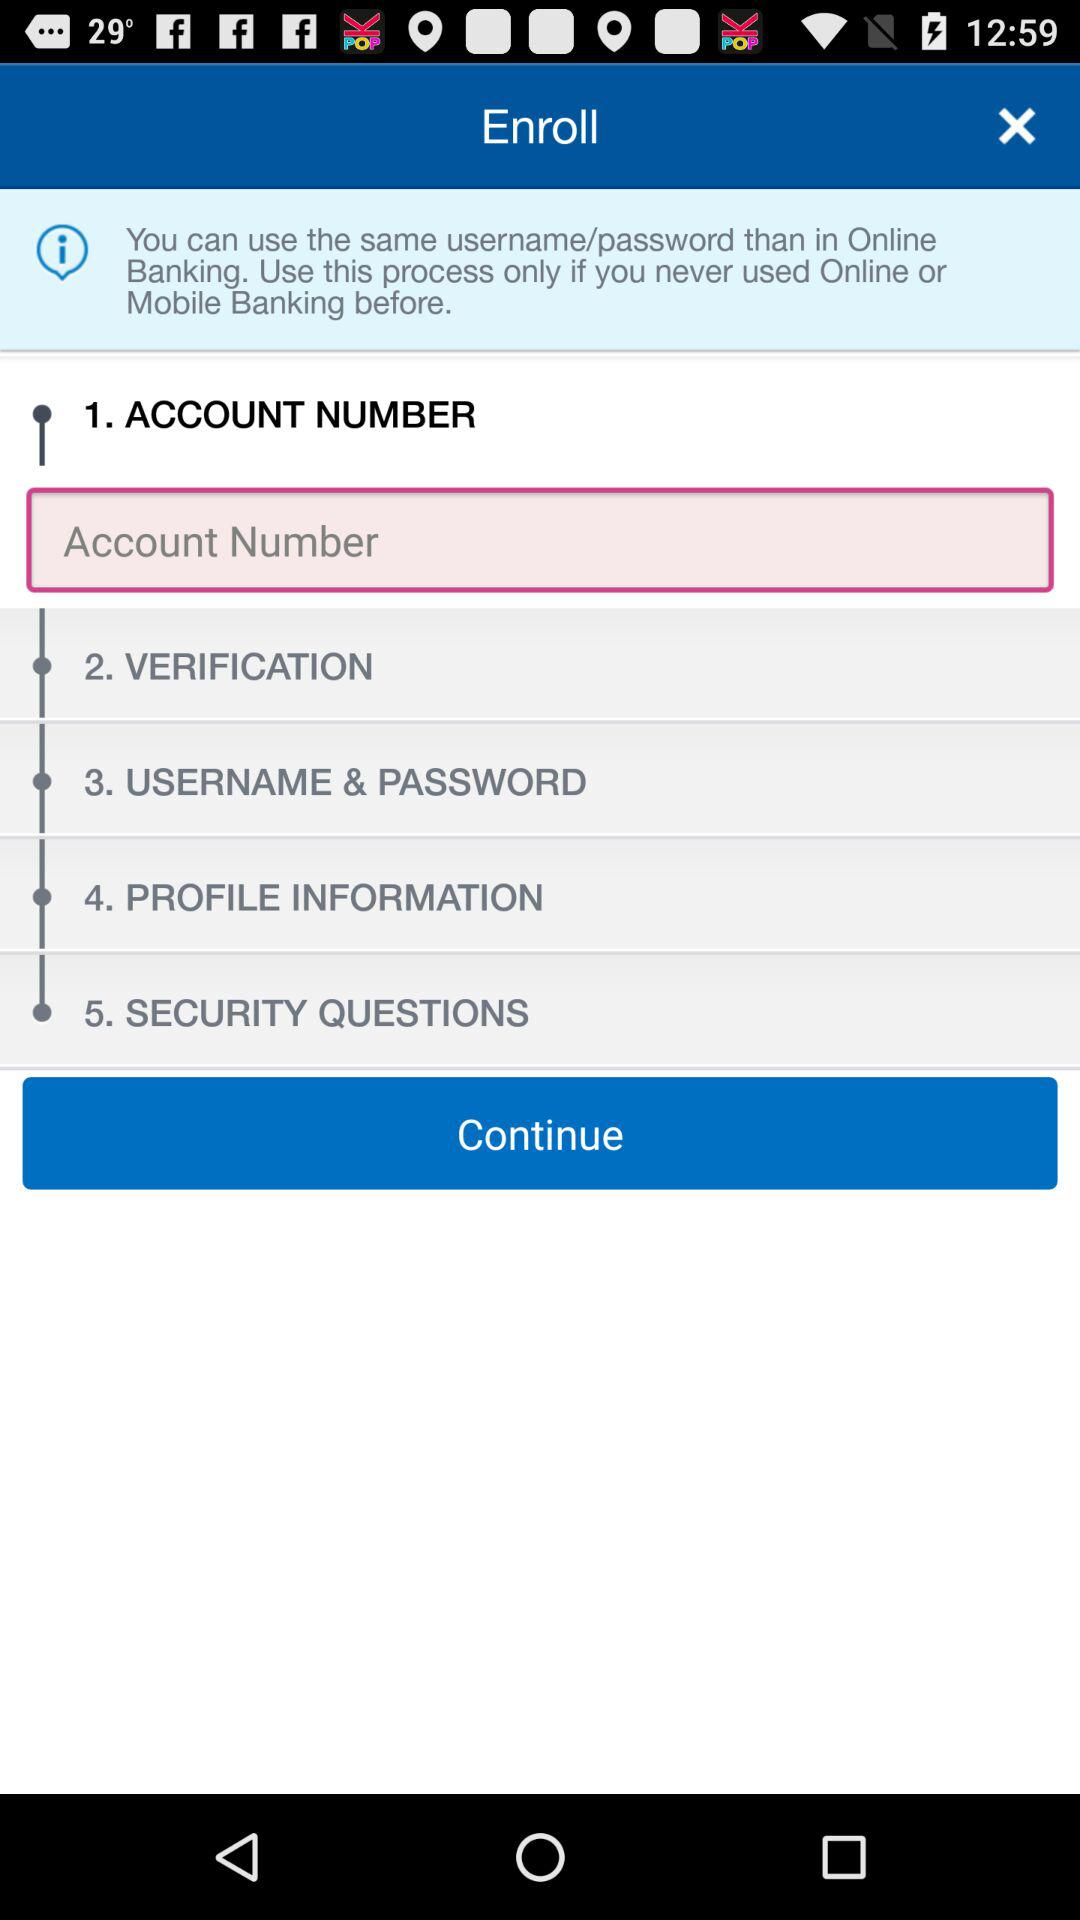How many steps are there in the enrollment process?
Answer the question using a single word or phrase. 5 